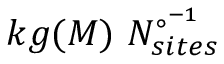Convert formula to latex. <formula><loc_0><loc_0><loc_500><loc_500>k g ( M ) \ N _ { s i t e s } ^ { { \circ } ^ { - 1 } }</formula> 